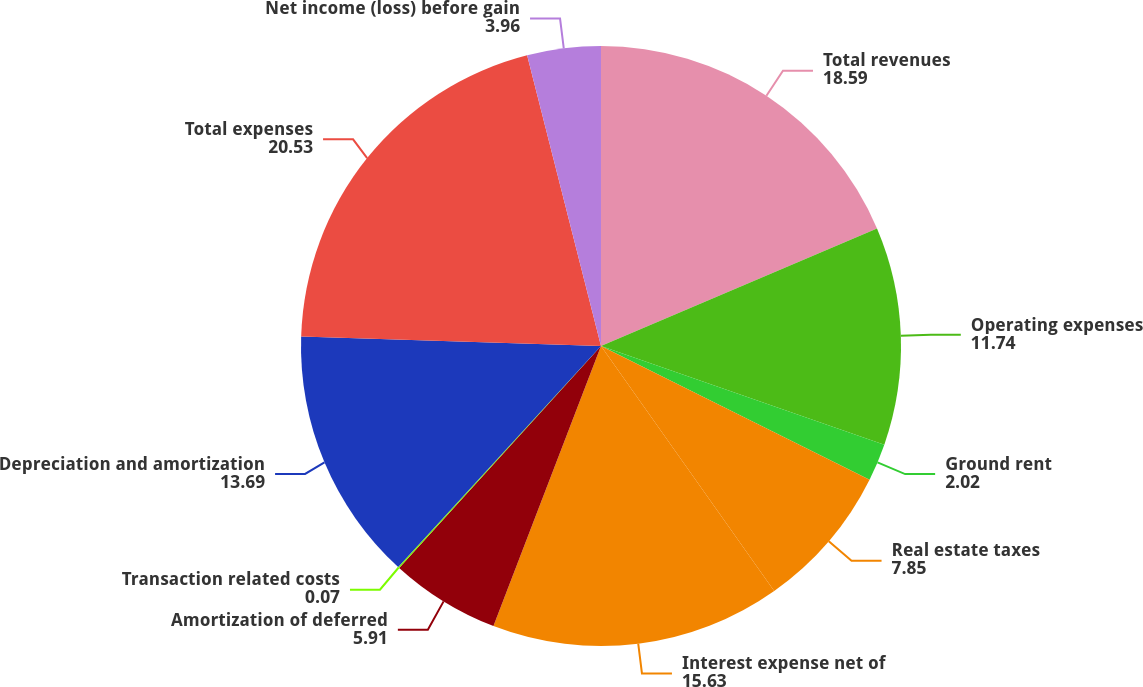Convert chart to OTSL. <chart><loc_0><loc_0><loc_500><loc_500><pie_chart><fcel>Total revenues<fcel>Operating expenses<fcel>Ground rent<fcel>Real estate taxes<fcel>Interest expense net of<fcel>Amortization of deferred<fcel>Transaction related costs<fcel>Depreciation and amortization<fcel>Total expenses<fcel>Net income (loss) before gain<nl><fcel>18.59%<fcel>11.74%<fcel>2.02%<fcel>7.85%<fcel>15.63%<fcel>5.91%<fcel>0.07%<fcel>13.69%<fcel>20.53%<fcel>3.96%<nl></chart> 